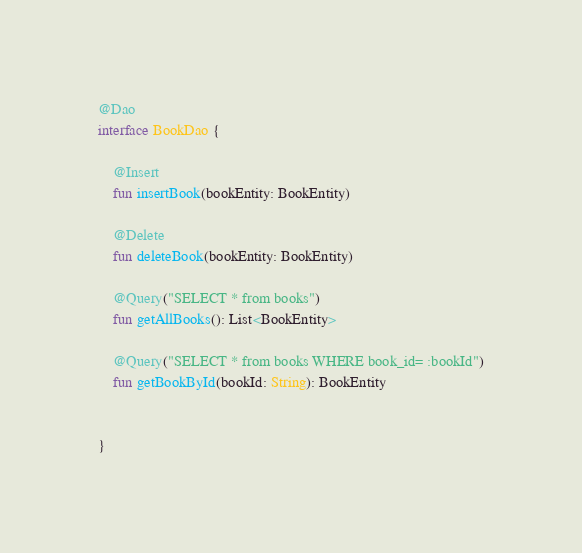<code> <loc_0><loc_0><loc_500><loc_500><_Kotlin_>
@Dao
interface BookDao {

    @Insert
    fun insertBook(bookEntity: BookEntity)

    @Delete
    fun deleteBook(bookEntity: BookEntity)

    @Query("SELECT * from books")
    fun getAllBooks(): List<BookEntity>

    @Query("SELECT * from books WHERE book_id= :bookId")
    fun getBookById(bookId: String): BookEntity


}</code> 